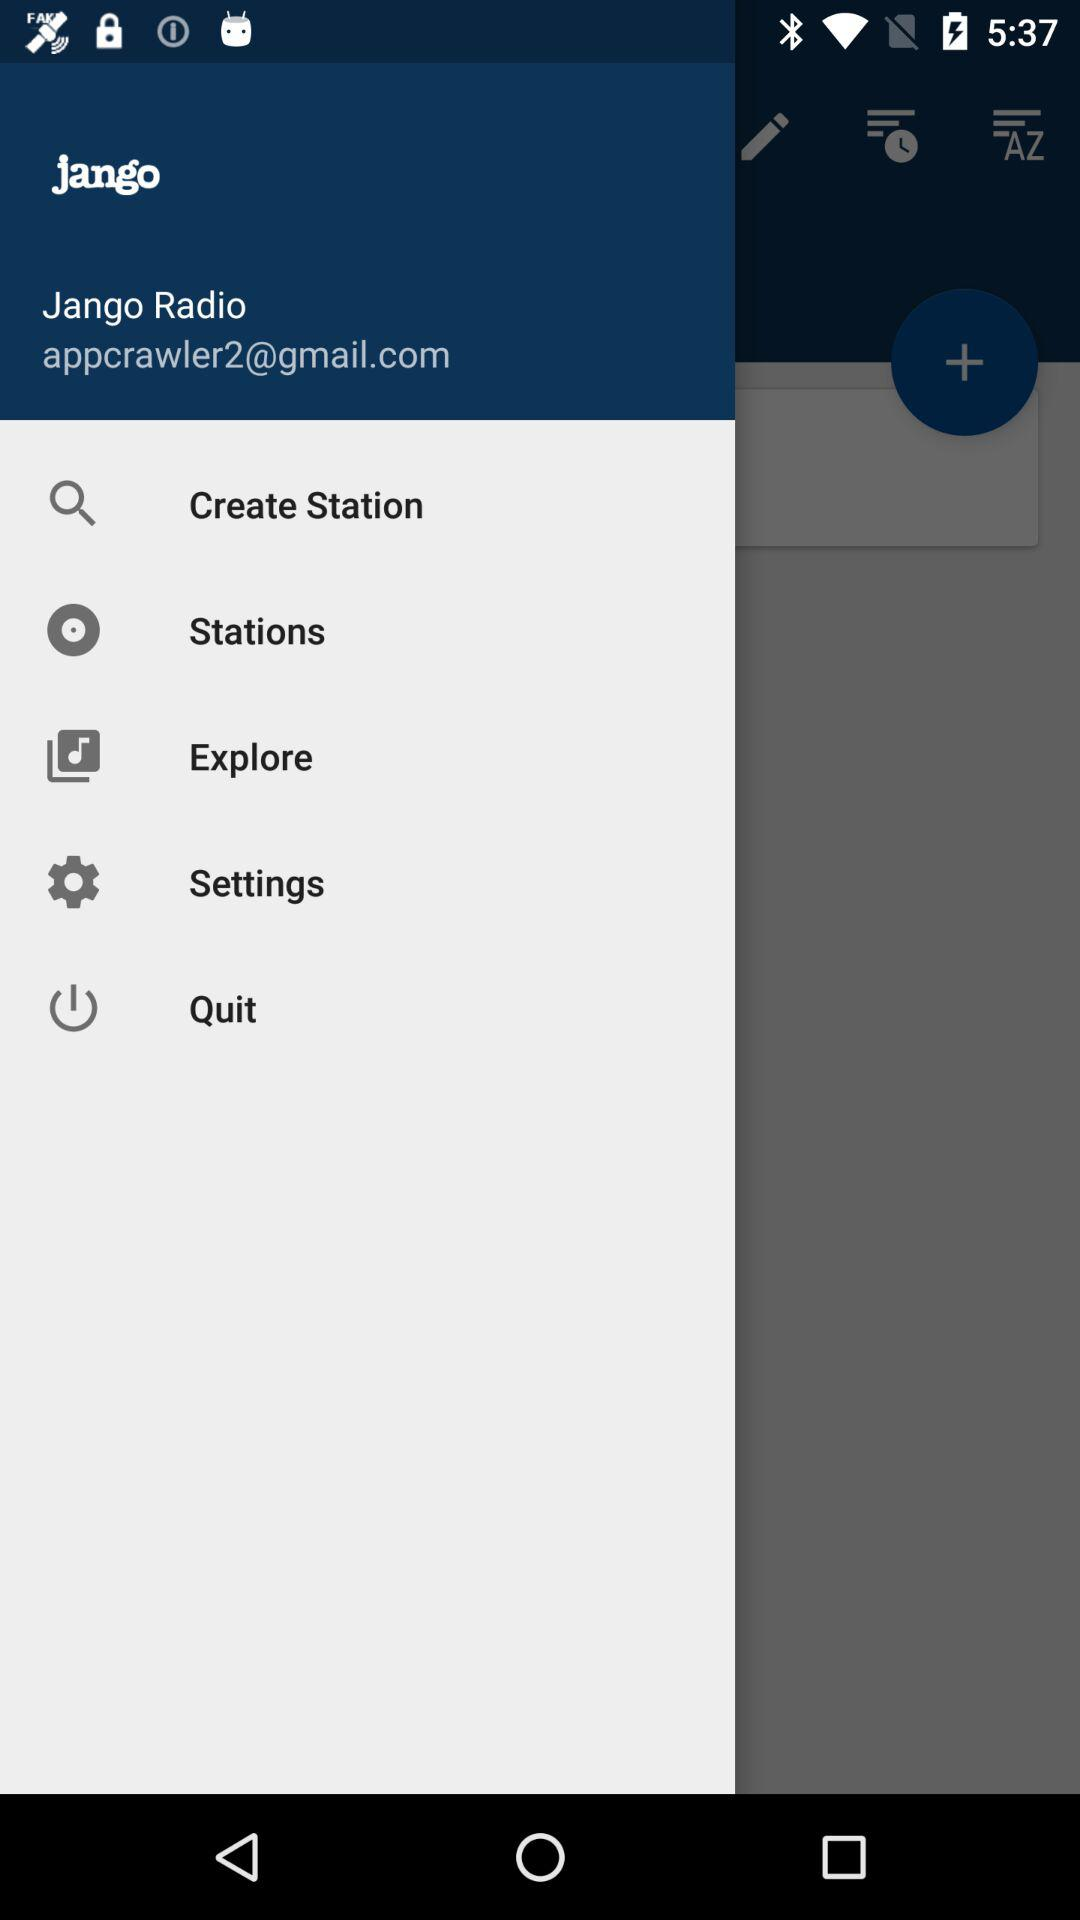Which Gmail address is used? The used Gmail address is appcrawler2@gmail.com. 